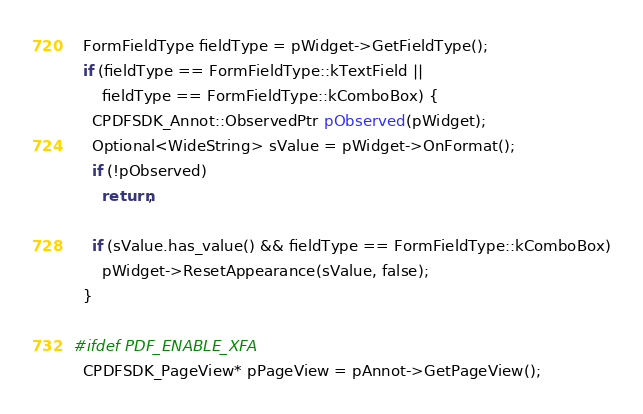Convert code to text. <code><loc_0><loc_0><loc_500><loc_500><_C++_>  FormFieldType fieldType = pWidget->GetFieldType();
  if (fieldType == FormFieldType::kTextField ||
      fieldType == FormFieldType::kComboBox) {
    CPDFSDK_Annot::ObservedPtr pObserved(pWidget);
    Optional<WideString> sValue = pWidget->OnFormat();
    if (!pObserved)
      return;

    if (sValue.has_value() && fieldType == FormFieldType::kComboBox)
      pWidget->ResetAppearance(sValue, false);
  }

#ifdef PDF_ENABLE_XFA
  CPDFSDK_PageView* pPageView = pAnnot->GetPageView();</code> 